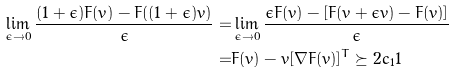Convert formula to latex. <formula><loc_0><loc_0><loc_500><loc_500>\lim _ { \epsilon \to 0 } \frac { ( 1 + \epsilon ) F ( v ) - F ( ( 1 + \epsilon ) v ) } { \epsilon } = & \lim _ { \epsilon \to 0 } \frac { \epsilon F ( v ) - [ F ( v + \epsilon v ) - F ( v ) ] } { \epsilon } \\ = & F ( v ) - v [ \nabla F ( v ) ] ^ { T } \succeq 2 c _ { 1 } 1</formula> 